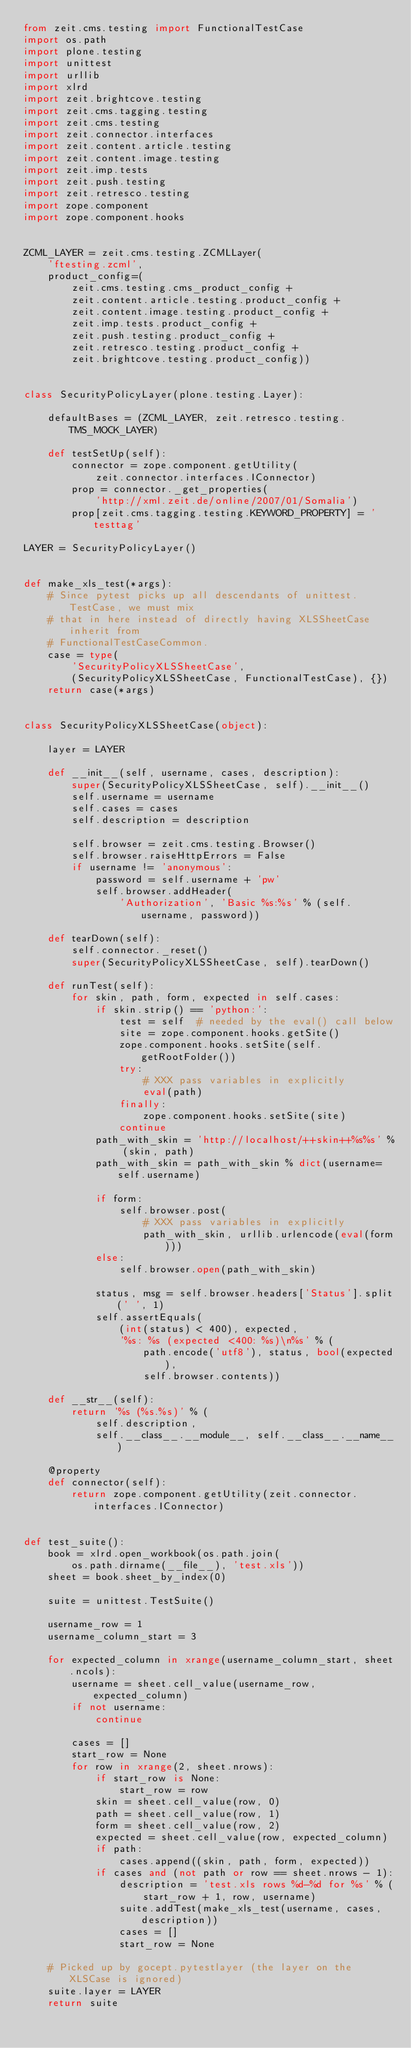<code> <loc_0><loc_0><loc_500><loc_500><_Python_>from zeit.cms.testing import FunctionalTestCase
import os.path
import plone.testing
import unittest
import urllib
import xlrd
import zeit.brightcove.testing
import zeit.cms.tagging.testing
import zeit.cms.testing
import zeit.connector.interfaces
import zeit.content.article.testing
import zeit.content.image.testing
import zeit.imp.tests
import zeit.push.testing
import zeit.retresco.testing
import zope.component
import zope.component.hooks


ZCML_LAYER = zeit.cms.testing.ZCMLLayer(
    'ftesting.zcml',
    product_config=(
        zeit.cms.testing.cms_product_config +
        zeit.content.article.testing.product_config +
        zeit.content.image.testing.product_config +
        zeit.imp.tests.product_config +
        zeit.push.testing.product_config +
        zeit.retresco.testing.product_config +
        zeit.brightcove.testing.product_config))


class SecurityPolicyLayer(plone.testing.Layer):

    defaultBases = (ZCML_LAYER, zeit.retresco.testing.TMS_MOCK_LAYER)

    def testSetUp(self):
        connector = zope.component.getUtility(
            zeit.connector.interfaces.IConnector)
        prop = connector._get_properties(
            'http://xml.zeit.de/online/2007/01/Somalia')
        prop[zeit.cms.tagging.testing.KEYWORD_PROPERTY] = 'testtag'

LAYER = SecurityPolicyLayer()


def make_xls_test(*args):
    # Since pytest picks up all descendants of unittest.TestCase, we must mix
    # that in here instead of directly having XLSSheetCase inherit from
    # FunctionalTestCaseCommon.
    case = type(
        'SecurityPolicyXLSSheetCase',
        (SecurityPolicyXLSSheetCase, FunctionalTestCase), {})
    return case(*args)


class SecurityPolicyXLSSheetCase(object):

    layer = LAYER

    def __init__(self, username, cases, description):
        super(SecurityPolicyXLSSheetCase, self).__init__()
        self.username = username
        self.cases = cases
        self.description = description

        self.browser = zeit.cms.testing.Browser()
        self.browser.raiseHttpErrors = False
        if username != 'anonymous':
            password = self.username + 'pw'
            self.browser.addHeader(
                'Authorization', 'Basic %s:%s' % (self.username, password))

    def tearDown(self):
        self.connector._reset()
        super(SecurityPolicyXLSSheetCase, self).tearDown()

    def runTest(self):
        for skin, path, form, expected in self.cases:
            if skin.strip() == 'python:':
                test = self  # needed by the eval() call below
                site = zope.component.hooks.getSite()
                zope.component.hooks.setSite(self.getRootFolder())
                try:
                    # XXX pass variables in explicitly
                    eval(path)
                finally:
                    zope.component.hooks.setSite(site)
                continue
            path_with_skin = 'http://localhost/++skin++%s%s' % (skin, path)
            path_with_skin = path_with_skin % dict(username=self.username)

            if form:
                self.browser.post(
                    # XXX pass variables in explicitly
                    path_with_skin, urllib.urlencode(eval(form)))
            else:
                self.browser.open(path_with_skin)

            status, msg = self.browser.headers['Status'].split(' ', 1)
            self.assertEquals(
                (int(status) < 400), expected,
                '%s: %s (expected <400: %s)\n%s' % (
                    path.encode('utf8'), status, bool(expected),
                    self.browser.contents))

    def __str__(self):
        return '%s (%s.%s)' % (
            self.description,
            self.__class__.__module__, self.__class__.__name__)

    @property
    def connector(self):
        return zope.component.getUtility(zeit.connector.interfaces.IConnector)


def test_suite():
    book = xlrd.open_workbook(os.path.join(
        os.path.dirname(__file__), 'test.xls'))
    sheet = book.sheet_by_index(0)

    suite = unittest.TestSuite()

    username_row = 1
    username_column_start = 3

    for expected_column in xrange(username_column_start, sheet.ncols):
        username = sheet.cell_value(username_row, expected_column)
        if not username:
            continue

        cases = []
        start_row = None
        for row in xrange(2, sheet.nrows):
            if start_row is None:
                start_row = row
            skin = sheet.cell_value(row, 0)
            path = sheet.cell_value(row, 1)
            form = sheet.cell_value(row, 2)
            expected = sheet.cell_value(row, expected_column)
            if path:
                cases.append((skin, path, form, expected))
            if cases and (not path or row == sheet.nrows - 1):
                description = 'test.xls rows %d-%d for %s' % (
                    start_row + 1, row, username)
                suite.addTest(make_xls_test(username, cases, description))
                cases = []
                start_row = None

    # Picked up by gocept.pytestlayer (the layer on the XLSCase is ignored)
    suite.layer = LAYER
    return suite
</code> 